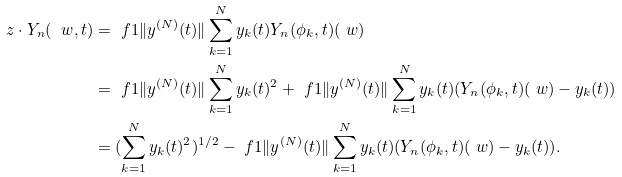Convert formula to latex. <formula><loc_0><loc_0><loc_500><loc_500>z \cdot Y _ { n } ( \ w , t ) & = \ f { 1 } { \| y ^ { ( N ) } ( t ) \| } \sum _ { k = 1 } ^ { N } y _ { k } ( t ) Y _ { n } ( \phi _ { k } , t ) ( \ w ) \\ & = \ f { 1 } { \| y ^ { ( N ) } ( t ) \| } \sum _ { k = 1 } ^ { N } y _ { k } ( t ) ^ { 2 } + \ f { 1 } { \| y ^ { ( N ) } ( t ) \| } \sum _ { k = 1 } ^ { N } y _ { k } ( t ) ( Y _ { n } ( \phi _ { k } , t ) ( \ w ) - y _ { k } ( t ) ) \\ & = ( \sum _ { k = 1 } ^ { N } y _ { k } ( t ) ^ { 2 } ) ^ { 1 / 2 } - \ f { 1 } { \| y ^ { ( N ) } ( t ) \| } \sum _ { k = 1 } ^ { N } y _ { k } ( t ) ( Y _ { n } ( \phi _ { k } , t ) ( \ w ) - y _ { k } ( t ) ) .</formula> 